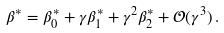Convert formula to latex. <formula><loc_0><loc_0><loc_500><loc_500>\beta ^ { * } = \beta ^ { * } _ { 0 } + \gamma \beta ^ { * } _ { 1 } + \gamma ^ { 2 } \beta ^ { * } _ { 2 } + \mathcal { O } ( \gamma ^ { 3 } ) \, .</formula> 